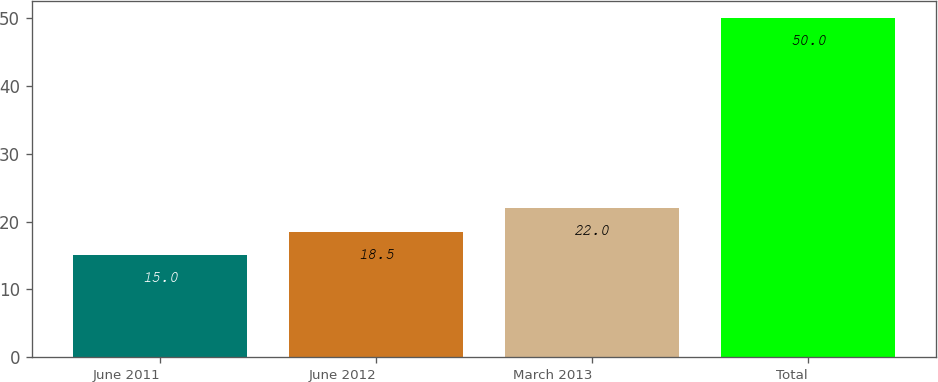Convert chart. <chart><loc_0><loc_0><loc_500><loc_500><bar_chart><fcel>June 2011<fcel>June 2012<fcel>March 2013<fcel>Total<nl><fcel>15<fcel>18.5<fcel>22<fcel>50<nl></chart> 